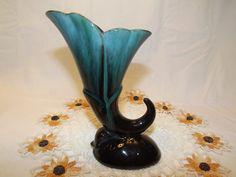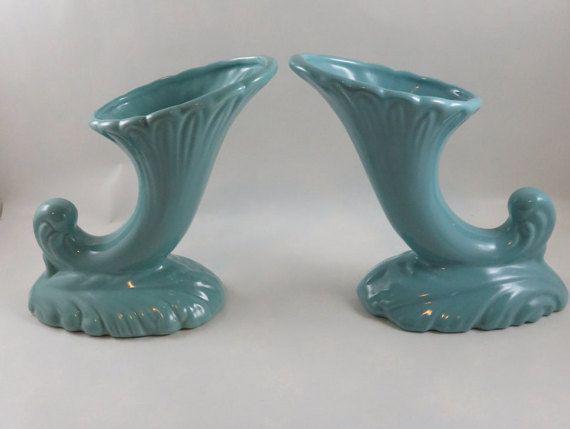The first image is the image on the left, the second image is the image on the right. Analyze the images presented: Is the assertion "The right image features a matched pair of vases." valid? Answer yes or no. Yes. The first image is the image on the left, the second image is the image on the right. For the images shown, is this caption "In one image, a vase with floral petal top design and scroll at the bottom is positioned in the center of a doily." true? Answer yes or no. Yes. 